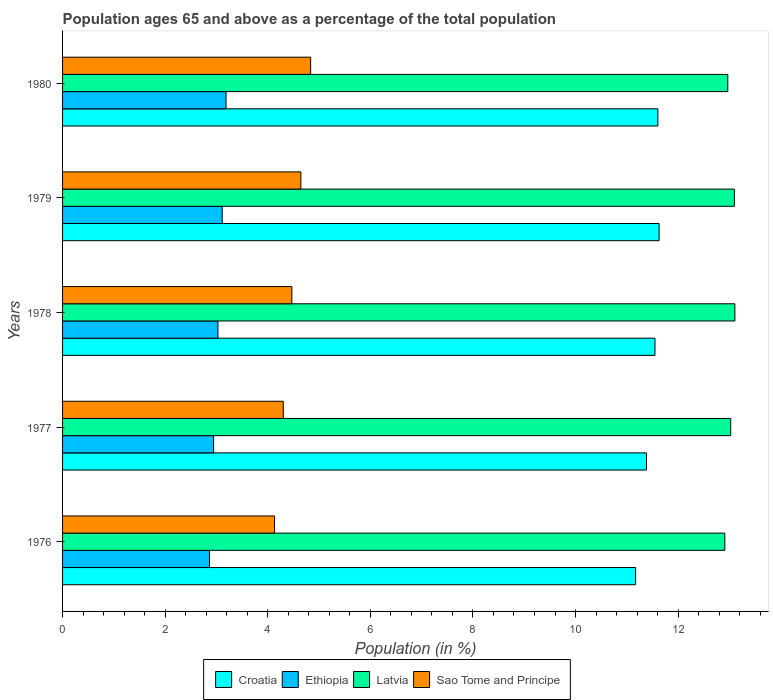How many different coloured bars are there?
Your answer should be compact. 4. Are the number of bars per tick equal to the number of legend labels?
Make the answer very short. Yes. How many bars are there on the 4th tick from the bottom?
Provide a short and direct response. 4. What is the label of the 2nd group of bars from the top?
Give a very brief answer. 1979. In how many cases, is the number of bars for a given year not equal to the number of legend labels?
Give a very brief answer. 0. What is the percentage of the population ages 65 and above in Ethiopia in 1977?
Ensure brevity in your answer.  2.94. Across all years, what is the maximum percentage of the population ages 65 and above in Sao Tome and Principe?
Your answer should be compact. 4.84. Across all years, what is the minimum percentage of the population ages 65 and above in Sao Tome and Principe?
Ensure brevity in your answer.  4.13. In which year was the percentage of the population ages 65 and above in Sao Tome and Principe minimum?
Provide a short and direct response. 1976. What is the total percentage of the population ages 65 and above in Sao Tome and Principe in the graph?
Ensure brevity in your answer.  22.39. What is the difference between the percentage of the population ages 65 and above in Sao Tome and Principe in 1977 and that in 1979?
Offer a terse response. -0.34. What is the difference between the percentage of the population ages 65 and above in Latvia in 1980 and the percentage of the population ages 65 and above in Ethiopia in 1978?
Provide a succinct answer. 9.94. What is the average percentage of the population ages 65 and above in Sao Tome and Principe per year?
Keep it short and to the point. 4.48. In the year 1977, what is the difference between the percentage of the population ages 65 and above in Ethiopia and percentage of the population ages 65 and above in Sao Tome and Principe?
Provide a short and direct response. -1.36. What is the ratio of the percentage of the population ages 65 and above in Ethiopia in 1977 to that in 1978?
Your answer should be very brief. 0.97. Is the percentage of the population ages 65 and above in Croatia in 1979 less than that in 1980?
Give a very brief answer. No. What is the difference between the highest and the second highest percentage of the population ages 65 and above in Sao Tome and Principe?
Offer a terse response. 0.19. What is the difference between the highest and the lowest percentage of the population ages 65 and above in Sao Tome and Principe?
Make the answer very short. 0.7. In how many years, is the percentage of the population ages 65 and above in Ethiopia greater than the average percentage of the population ages 65 and above in Ethiopia taken over all years?
Provide a succinct answer. 3. Is it the case that in every year, the sum of the percentage of the population ages 65 and above in Sao Tome and Principe and percentage of the population ages 65 and above in Latvia is greater than the sum of percentage of the population ages 65 and above in Ethiopia and percentage of the population ages 65 and above in Croatia?
Make the answer very short. Yes. What does the 1st bar from the top in 1977 represents?
Offer a terse response. Sao Tome and Principe. What does the 4th bar from the bottom in 1976 represents?
Offer a very short reply. Sao Tome and Principe. How many years are there in the graph?
Give a very brief answer. 5. Are the values on the major ticks of X-axis written in scientific E-notation?
Keep it short and to the point. No. Does the graph contain any zero values?
Your answer should be very brief. No. Does the graph contain grids?
Your answer should be very brief. No. Where does the legend appear in the graph?
Offer a very short reply. Bottom center. How many legend labels are there?
Keep it short and to the point. 4. How are the legend labels stacked?
Make the answer very short. Horizontal. What is the title of the graph?
Make the answer very short. Population ages 65 and above as a percentage of the total population. What is the Population (in %) of Croatia in 1976?
Keep it short and to the point. 11.17. What is the Population (in %) of Ethiopia in 1976?
Your response must be concise. 2.86. What is the Population (in %) in Latvia in 1976?
Ensure brevity in your answer.  12.91. What is the Population (in %) of Sao Tome and Principe in 1976?
Provide a short and direct response. 4.13. What is the Population (in %) in Croatia in 1977?
Ensure brevity in your answer.  11.38. What is the Population (in %) of Ethiopia in 1977?
Give a very brief answer. 2.94. What is the Population (in %) of Latvia in 1977?
Make the answer very short. 13.02. What is the Population (in %) in Sao Tome and Principe in 1977?
Offer a terse response. 4.3. What is the Population (in %) of Croatia in 1978?
Your response must be concise. 11.55. What is the Population (in %) of Ethiopia in 1978?
Offer a terse response. 3.03. What is the Population (in %) in Latvia in 1978?
Your answer should be compact. 13.11. What is the Population (in %) of Sao Tome and Principe in 1978?
Provide a short and direct response. 4.47. What is the Population (in %) of Croatia in 1979?
Offer a terse response. 11.63. What is the Population (in %) in Ethiopia in 1979?
Provide a short and direct response. 3.11. What is the Population (in %) of Latvia in 1979?
Give a very brief answer. 13.1. What is the Population (in %) in Sao Tome and Principe in 1979?
Your answer should be compact. 4.65. What is the Population (in %) in Croatia in 1980?
Offer a terse response. 11.61. What is the Population (in %) in Ethiopia in 1980?
Your answer should be compact. 3.19. What is the Population (in %) in Latvia in 1980?
Ensure brevity in your answer.  12.97. What is the Population (in %) in Sao Tome and Principe in 1980?
Offer a very short reply. 4.84. Across all years, what is the maximum Population (in %) of Croatia?
Provide a succinct answer. 11.63. Across all years, what is the maximum Population (in %) of Ethiopia?
Your answer should be very brief. 3.19. Across all years, what is the maximum Population (in %) in Latvia?
Your response must be concise. 13.11. Across all years, what is the maximum Population (in %) of Sao Tome and Principe?
Keep it short and to the point. 4.84. Across all years, what is the minimum Population (in %) in Croatia?
Provide a short and direct response. 11.17. Across all years, what is the minimum Population (in %) in Ethiopia?
Your answer should be very brief. 2.86. Across all years, what is the minimum Population (in %) in Latvia?
Keep it short and to the point. 12.91. Across all years, what is the minimum Population (in %) in Sao Tome and Principe?
Your answer should be very brief. 4.13. What is the total Population (in %) of Croatia in the graph?
Your answer should be compact. 57.34. What is the total Population (in %) in Ethiopia in the graph?
Make the answer very short. 15.14. What is the total Population (in %) in Latvia in the graph?
Your answer should be very brief. 65.11. What is the total Population (in %) of Sao Tome and Principe in the graph?
Offer a very short reply. 22.39. What is the difference between the Population (in %) of Croatia in 1976 and that in 1977?
Make the answer very short. -0.21. What is the difference between the Population (in %) in Ethiopia in 1976 and that in 1977?
Offer a very short reply. -0.08. What is the difference between the Population (in %) of Latvia in 1976 and that in 1977?
Your answer should be compact. -0.11. What is the difference between the Population (in %) of Sao Tome and Principe in 1976 and that in 1977?
Provide a short and direct response. -0.17. What is the difference between the Population (in %) in Croatia in 1976 and that in 1978?
Provide a short and direct response. -0.38. What is the difference between the Population (in %) in Ethiopia in 1976 and that in 1978?
Your response must be concise. -0.17. What is the difference between the Population (in %) of Latvia in 1976 and that in 1978?
Your answer should be compact. -0.2. What is the difference between the Population (in %) of Sao Tome and Principe in 1976 and that in 1978?
Make the answer very short. -0.34. What is the difference between the Population (in %) of Croatia in 1976 and that in 1979?
Offer a terse response. -0.46. What is the difference between the Population (in %) in Ethiopia in 1976 and that in 1979?
Make the answer very short. -0.25. What is the difference between the Population (in %) of Latvia in 1976 and that in 1979?
Provide a succinct answer. -0.19. What is the difference between the Population (in %) in Sao Tome and Principe in 1976 and that in 1979?
Provide a succinct answer. -0.51. What is the difference between the Population (in %) of Croatia in 1976 and that in 1980?
Offer a terse response. -0.43. What is the difference between the Population (in %) of Ethiopia in 1976 and that in 1980?
Provide a short and direct response. -0.32. What is the difference between the Population (in %) of Latvia in 1976 and that in 1980?
Your answer should be very brief. -0.06. What is the difference between the Population (in %) of Sao Tome and Principe in 1976 and that in 1980?
Make the answer very short. -0.7. What is the difference between the Population (in %) of Croatia in 1977 and that in 1978?
Your response must be concise. -0.17. What is the difference between the Population (in %) in Ethiopia in 1977 and that in 1978?
Make the answer very short. -0.08. What is the difference between the Population (in %) of Latvia in 1977 and that in 1978?
Ensure brevity in your answer.  -0.08. What is the difference between the Population (in %) in Sao Tome and Principe in 1977 and that in 1978?
Give a very brief answer. -0.17. What is the difference between the Population (in %) of Croatia in 1977 and that in 1979?
Give a very brief answer. -0.25. What is the difference between the Population (in %) of Ethiopia in 1977 and that in 1979?
Your answer should be very brief. -0.17. What is the difference between the Population (in %) of Latvia in 1977 and that in 1979?
Your answer should be very brief. -0.07. What is the difference between the Population (in %) in Sao Tome and Principe in 1977 and that in 1979?
Your answer should be compact. -0.34. What is the difference between the Population (in %) in Croatia in 1977 and that in 1980?
Keep it short and to the point. -0.22. What is the difference between the Population (in %) of Ethiopia in 1977 and that in 1980?
Provide a succinct answer. -0.24. What is the difference between the Population (in %) in Latvia in 1977 and that in 1980?
Your answer should be compact. 0.06. What is the difference between the Population (in %) of Sao Tome and Principe in 1977 and that in 1980?
Keep it short and to the point. -0.53. What is the difference between the Population (in %) in Croatia in 1978 and that in 1979?
Your response must be concise. -0.08. What is the difference between the Population (in %) in Ethiopia in 1978 and that in 1979?
Offer a terse response. -0.08. What is the difference between the Population (in %) in Latvia in 1978 and that in 1979?
Offer a very short reply. 0.01. What is the difference between the Population (in %) in Sao Tome and Principe in 1978 and that in 1979?
Your response must be concise. -0.18. What is the difference between the Population (in %) in Croatia in 1978 and that in 1980?
Provide a short and direct response. -0.06. What is the difference between the Population (in %) in Ethiopia in 1978 and that in 1980?
Your answer should be very brief. -0.16. What is the difference between the Population (in %) of Latvia in 1978 and that in 1980?
Give a very brief answer. 0.14. What is the difference between the Population (in %) of Sao Tome and Principe in 1978 and that in 1980?
Offer a terse response. -0.37. What is the difference between the Population (in %) in Croatia in 1979 and that in 1980?
Offer a terse response. 0.02. What is the difference between the Population (in %) of Ethiopia in 1979 and that in 1980?
Offer a terse response. -0.07. What is the difference between the Population (in %) in Latvia in 1979 and that in 1980?
Offer a terse response. 0.13. What is the difference between the Population (in %) of Sao Tome and Principe in 1979 and that in 1980?
Give a very brief answer. -0.19. What is the difference between the Population (in %) of Croatia in 1976 and the Population (in %) of Ethiopia in 1977?
Offer a very short reply. 8.23. What is the difference between the Population (in %) of Croatia in 1976 and the Population (in %) of Latvia in 1977?
Your response must be concise. -1.85. What is the difference between the Population (in %) in Croatia in 1976 and the Population (in %) in Sao Tome and Principe in 1977?
Provide a short and direct response. 6.87. What is the difference between the Population (in %) in Ethiopia in 1976 and the Population (in %) in Latvia in 1977?
Your answer should be compact. -10.16. What is the difference between the Population (in %) of Ethiopia in 1976 and the Population (in %) of Sao Tome and Principe in 1977?
Your answer should be compact. -1.44. What is the difference between the Population (in %) of Latvia in 1976 and the Population (in %) of Sao Tome and Principe in 1977?
Provide a short and direct response. 8.61. What is the difference between the Population (in %) of Croatia in 1976 and the Population (in %) of Ethiopia in 1978?
Offer a terse response. 8.14. What is the difference between the Population (in %) of Croatia in 1976 and the Population (in %) of Latvia in 1978?
Give a very brief answer. -1.94. What is the difference between the Population (in %) of Croatia in 1976 and the Population (in %) of Sao Tome and Principe in 1978?
Your answer should be compact. 6.7. What is the difference between the Population (in %) in Ethiopia in 1976 and the Population (in %) in Latvia in 1978?
Your response must be concise. -10.24. What is the difference between the Population (in %) of Ethiopia in 1976 and the Population (in %) of Sao Tome and Principe in 1978?
Your answer should be compact. -1.61. What is the difference between the Population (in %) of Latvia in 1976 and the Population (in %) of Sao Tome and Principe in 1978?
Your answer should be very brief. 8.44. What is the difference between the Population (in %) in Croatia in 1976 and the Population (in %) in Ethiopia in 1979?
Make the answer very short. 8.06. What is the difference between the Population (in %) in Croatia in 1976 and the Population (in %) in Latvia in 1979?
Make the answer very short. -1.93. What is the difference between the Population (in %) in Croatia in 1976 and the Population (in %) in Sao Tome and Principe in 1979?
Provide a succinct answer. 6.53. What is the difference between the Population (in %) of Ethiopia in 1976 and the Population (in %) of Latvia in 1979?
Your response must be concise. -10.23. What is the difference between the Population (in %) of Ethiopia in 1976 and the Population (in %) of Sao Tome and Principe in 1979?
Your answer should be compact. -1.78. What is the difference between the Population (in %) in Latvia in 1976 and the Population (in %) in Sao Tome and Principe in 1979?
Your response must be concise. 8.26. What is the difference between the Population (in %) of Croatia in 1976 and the Population (in %) of Ethiopia in 1980?
Provide a short and direct response. 7.98. What is the difference between the Population (in %) of Croatia in 1976 and the Population (in %) of Latvia in 1980?
Provide a succinct answer. -1.8. What is the difference between the Population (in %) in Croatia in 1976 and the Population (in %) in Sao Tome and Principe in 1980?
Offer a very short reply. 6.34. What is the difference between the Population (in %) of Ethiopia in 1976 and the Population (in %) of Latvia in 1980?
Offer a very short reply. -10.11. What is the difference between the Population (in %) of Ethiopia in 1976 and the Population (in %) of Sao Tome and Principe in 1980?
Give a very brief answer. -1.97. What is the difference between the Population (in %) of Latvia in 1976 and the Population (in %) of Sao Tome and Principe in 1980?
Offer a terse response. 8.07. What is the difference between the Population (in %) of Croatia in 1977 and the Population (in %) of Ethiopia in 1978?
Make the answer very short. 8.35. What is the difference between the Population (in %) in Croatia in 1977 and the Population (in %) in Latvia in 1978?
Provide a succinct answer. -1.72. What is the difference between the Population (in %) of Croatia in 1977 and the Population (in %) of Sao Tome and Principe in 1978?
Your answer should be very brief. 6.91. What is the difference between the Population (in %) of Ethiopia in 1977 and the Population (in %) of Latvia in 1978?
Provide a short and direct response. -10.16. What is the difference between the Population (in %) in Ethiopia in 1977 and the Population (in %) in Sao Tome and Principe in 1978?
Make the answer very short. -1.53. What is the difference between the Population (in %) in Latvia in 1977 and the Population (in %) in Sao Tome and Principe in 1978?
Ensure brevity in your answer.  8.56. What is the difference between the Population (in %) of Croatia in 1977 and the Population (in %) of Ethiopia in 1979?
Give a very brief answer. 8.27. What is the difference between the Population (in %) in Croatia in 1977 and the Population (in %) in Latvia in 1979?
Your answer should be very brief. -1.71. What is the difference between the Population (in %) of Croatia in 1977 and the Population (in %) of Sao Tome and Principe in 1979?
Give a very brief answer. 6.74. What is the difference between the Population (in %) of Ethiopia in 1977 and the Population (in %) of Latvia in 1979?
Offer a terse response. -10.15. What is the difference between the Population (in %) of Ethiopia in 1977 and the Population (in %) of Sao Tome and Principe in 1979?
Ensure brevity in your answer.  -1.7. What is the difference between the Population (in %) of Latvia in 1977 and the Population (in %) of Sao Tome and Principe in 1979?
Offer a very short reply. 8.38. What is the difference between the Population (in %) in Croatia in 1977 and the Population (in %) in Ethiopia in 1980?
Make the answer very short. 8.2. What is the difference between the Population (in %) of Croatia in 1977 and the Population (in %) of Latvia in 1980?
Ensure brevity in your answer.  -1.59. What is the difference between the Population (in %) in Croatia in 1977 and the Population (in %) in Sao Tome and Principe in 1980?
Provide a short and direct response. 6.55. What is the difference between the Population (in %) in Ethiopia in 1977 and the Population (in %) in Latvia in 1980?
Your response must be concise. -10.02. What is the difference between the Population (in %) in Ethiopia in 1977 and the Population (in %) in Sao Tome and Principe in 1980?
Offer a very short reply. -1.89. What is the difference between the Population (in %) of Latvia in 1977 and the Population (in %) of Sao Tome and Principe in 1980?
Your answer should be compact. 8.19. What is the difference between the Population (in %) of Croatia in 1978 and the Population (in %) of Ethiopia in 1979?
Keep it short and to the point. 8.44. What is the difference between the Population (in %) of Croatia in 1978 and the Population (in %) of Latvia in 1979?
Offer a very short reply. -1.55. What is the difference between the Population (in %) of Croatia in 1978 and the Population (in %) of Sao Tome and Principe in 1979?
Your answer should be very brief. 6.9. What is the difference between the Population (in %) in Ethiopia in 1978 and the Population (in %) in Latvia in 1979?
Your answer should be compact. -10.07. What is the difference between the Population (in %) in Ethiopia in 1978 and the Population (in %) in Sao Tome and Principe in 1979?
Offer a terse response. -1.62. What is the difference between the Population (in %) in Latvia in 1978 and the Population (in %) in Sao Tome and Principe in 1979?
Give a very brief answer. 8.46. What is the difference between the Population (in %) of Croatia in 1978 and the Population (in %) of Ethiopia in 1980?
Ensure brevity in your answer.  8.36. What is the difference between the Population (in %) of Croatia in 1978 and the Population (in %) of Latvia in 1980?
Make the answer very short. -1.42. What is the difference between the Population (in %) of Croatia in 1978 and the Population (in %) of Sao Tome and Principe in 1980?
Your answer should be compact. 6.71. What is the difference between the Population (in %) of Ethiopia in 1978 and the Population (in %) of Latvia in 1980?
Offer a very short reply. -9.94. What is the difference between the Population (in %) in Ethiopia in 1978 and the Population (in %) in Sao Tome and Principe in 1980?
Your response must be concise. -1.81. What is the difference between the Population (in %) in Latvia in 1978 and the Population (in %) in Sao Tome and Principe in 1980?
Make the answer very short. 8.27. What is the difference between the Population (in %) in Croatia in 1979 and the Population (in %) in Ethiopia in 1980?
Your answer should be very brief. 8.44. What is the difference between the Population (in %) in Croatia in 1979 and the Population (in %) in Latvia in 1980?
Provide a succinct answer. -1.34. What is the difference between the Population (in %) of Croatia in 1979 and the Population (in %) of Sao Tome and Principe in 1980?
Provide a succinct answer. 6.79. What is the difference between the Population (in %) of Ethiopia in 1979 and the Population (in %) of Latvia in 1980?
Give a very brief answer. -9.86. What is the difference between the Population (in %) in Ethiopia in 1979 and the Population (in %) in Sao Tome and Principe in 1980?
Offer a terse response. -1.72. What is the difference between the Population (in %) in Latvia in 1979 and the Population (in %) in Sao Tome and Principe in 1980?
Keep it short and to the point. 8.26. What is the average Population (in %) of Croatia per year?
Ensure brevity in your answer.  11.47. What is the average Population (in %) in Ethiopia per year?
Give a very brief answer. 3.03. What is the average Population (in %) in Latvia per year?
Ensure brevity in your answer.  13.02. What is the average Population (in %) of Sao Tome and Principe per year?
Provide a short and direct response. 4.48. In the year 1976, what is the difference between the Population (in %) in Croatia and Population (in %) in Ethiopia?
Make the answer very short. 8.31. In the year 1976, what is the difference between the Population (in %) in Croatia and Population (in %) in Latvia?
Offer a terse response. -1.74. In the year 1976, what is the difference between the Population (in %) in Croatia and Population (in %) in Sao Tome and Principe?
Offer a very short reply. 7.04. In the year 1976, what is the difference between the Population (in %) in Ethiopia and Population (in %) in Latvia?
Offer a very short reply. -10.05. In the year 1976, what is the difference between the Population (in %) in Ethiopia and Population (in %) in Sao Tome and Principe?
Keep it short and to the point. -1.27. In the year 1976, what is the difference between the Population (in %) in Latvia and Population (in %) in Sao Tome and Principe?
Provide a succinct answer. 8.78. In the year 1977, what is the difference between the Population (in %) in Croatia and Population (in %) in Ethiopia?
Your response must be concise. 8.44. In the year 1977, what is the difference between the Population (in %) in Croatia and Population (in %) in Latvia?
Provide a succinct answer. -1.64. In the year 1977, what is the difference between the Population (in %) in Croatia and Population (in %) in Sao Tome and Principe?
Your response must be concise. 7.08. In the year 1977, what is the difference between the Population (in %) of Ethiopia and Population (in %) of Latvia?
Your response must be concise. -10.08. In the year 1977, what is the difference between the Population (in %) in Ethiopia and Population (in %) in Sao Tome and Principe?
Your answer should be compact. -1.36. In the year 1977, what is the difference between the Population (in %) of Latvia and Population (in %) of Sao Tome and Principe?
Offer a very short reply. 8.72. In the year 1978, what is the difference between the Population (in %) of Croatia and Population (in %) of Ethiopia?
Keep it short and to the point. 8.52. In the year 1978, what is the difference between the Population (in %) in Croatia and Population (in %) in Latvia?
Your response must be concise. -1.56. In the year 1978, what is the difference between the Population (in %) of Croatia and Population (in %) of Sao Tome and Principe?
Make the answer very short. 7.08. In the year 1978, what is the difference between the Population (in %) of Ethiopia and Population (in %) of Latvia?
Give a very brief answer. -10.08. In the year 1978, what is the difference between the Population (in %) of Ethiopia and Population (in %) of Sao Tome and Principe?
Offer a very short reply. -1.44. In the year 1978, what is the difference between the Population (in %) of Latvia and Population (in %) of Sao Tome and Principe?
Make the answer very short. 8.64. In the year 1979, what is the difference between the Population (in %) of Croatia and Population (in %) of Ethiopia?
Your answer should be very brief. 8.52. In the year 1979, what is the difference between the Population (in %) of Croatia and Population (in %) of Latvia?
Make the answer very short. -1.47. In the year 1979, what is the difference between the Population (in %) of Croatia and Population (in %) of Sao Tome and Principe?
Provide a succinct answer. 6.98. In the year 1979, what is the difference between the Population (in %) of Ethiopia and Population (in %) of Latvia?
Your answer should be very brief. -9.98. In the year 1979, what is the difference between the Population (in %) of Ethiopia and Population (in %) of Sao Tome and Principe?
Give a very brief answer. -1.53. In the year 1979, what is the difference between the Population (in %) in Latvia and Population (in %) in Sao Tome and Principe?
Provide a short and direct response. 8.45. In the year 1980, what is the difference between the Population (in %) in Croatia and Population (in %) in Ethiopia?
Provide a short and direct response. 8.42. In the year 1980, what is the difference between the Population (in %) of Croatia and Population (in %) of Latvia?
Your response must be concise. -1.36. In the year 1980, what is the difference between the Population (in %) of Croatia and Population (in %) of Sao Tome and Principe?
Your answer should be compact. 6.77. In the year 1980, what is the difference between the Population (in %) in Ethiopia and Population (in %) in Latvia?
Make the answer very short. -9.78. In the year 1980, what is the difference between the Population (in %) of Ethiopia and Population (in %) of Sao Tome and Principe?
Offer a terse response. -1.65. In the year 1980, what is the difference between the Population (in %) of Latvia and Population (in %) of Sao Tome and Principe?
Ensure brevity in your answer.  8.13. What is the ratio of the Population (in %) in Croatia in 1976 to that in 1977?
Your answer should be very brief. 0.98. What is the ratio of the Population (in %) of Ethiopia in 1976 to that in 1977?
Ensure brevity in your answer.  0.97. What is the ratio of the Population (in %) of Latvia in 1976 to that in 1977?
Your response must be concise. 0.99. What is the ratio of the Population (in %) in Sao Tome and Principe in 1976 to that in 1977?
Provide a short and direct response. 0.96. What is the ratio of the Population (in %) of Croatia in 1976 to that in 1978?
Ensure brevity in your answer.  0.97. What is the ratio of the Population (in %) in Ethiopia in 1976 to that in 1978?
Keep it short and to the point. 0.95. What is the ratio of the Population (in %) of Latvia in 1976 to that in 1978?
Provide a short and direct response. 0.98. What is the ratio of the Population (in %) in Sao Tome and Principe in 1976 to that in 1978?
Your response must be concise. 0.92. What is the ratio of the Population (in %) in Croatia in 1976 to that in 1979?
Offer a very short reply. 0.96. What is the ratio of the Population (in %) in Latvia in 1976 to that in 1979?
Your response must be concise. 0.99. What is the ratio of the Population (in %) in Sao Tome and Principe in 1976 to that in 1979?
Offer a terse response. 0.89. What is the ratio of the Population (in %) of Croatia in 1976 to that in 1980?
Provide a short and direct response. 0.96. What is the ratio of the Population (in %) of Ethiopia in 1976 to that in 1980?
Give a very brief answer. 0.9. What is the ratio of the Population (in %) of Sao Tome and Principe in 1976 to that in 1980?
Offer a very short reply. 0.85. What is the ratio of the Population (in %) in Croatia in 1977 to that in 1978?
Provide a succinct answer. 0.99. What is the ratio of the Population (in %) of Sao Tome and Principe in 1977 to that in 1978?
Your response must be concise. 0.96. What is the ratio of the Population (in %) in Croatia in 1977 to that in 1979?
Your response must be concise. 0.98. What is the ratio of the Population (in %) in Ethiopia in 1977 to that in 1979?
Keep it short and to the point. 0.95. What is the ratio of the Population (in %) in Latvia in 1977 to that in 1979?
Ensure brevity in your answer.  0.99. What is the ratio of the Population (in %) of Sao Tome and Principe in 1977 to that in 1979?
Your response must be concise. 0.93. What is the ratio of the Population (in %) of Croatia in 1977 to that in 1980?
Offer a very short reply. 0.98. What is the ratio of the Population (in %) of Ethiopia in 1977 to that in 1980?
Provide a succinct answer. 0.92. What is the ratio of the Population (in %) in Latvia in 1977 to that in 1980?
Provide a short and direct response. 1. What is the ratio of the Population (in %) in Sao Tome and Principe in 1977 to that in 1980?
Your answer should be compact. 0.89. What is the ratio of the Population (in %) of Croatia in 1978 to that in 1979?
Give a very brief answer. 0.99. What is the ratio of the Population (in %) of Ethiopia in 1978 to that in 1979?
Your answer should be compact. 0.97. What is the ratio of the Population (in %) in Latvia in 1978 to that in 1979?
Your answer should be compact. 1. What is the ratio of the Population (in %) in Sao Tome and Principe in 1978 to that in 1979?
Your response must be concise. 0.96. What is the ratio of the Population (in %) of Croatia in 1978 to that in 1980?
Make the answer very short. 1. What is the ratio of the Population (in %) of Ethiopia in 1978 to that in 1980?
Your response must be concise. 0.95. What is the ratio of the Population (in %) of Latvia in 1978 to that in 1980?
Provide a short and direct response. 1.01. What is the ratio of the Population (in %) in Sao Tome and Principe in 1978 to that in 1980?
Keep it short and to the point. 0.92. What is the ratio of the Population (in %) in Croatia in 1979 to that in 1980?
Ensure brevity in your answer.  1. What is the ratio of the Population (in %) of Ethiopia in 1979 to that in 1980?
Ensure brevity in your answer.  0.98. What is the ratio of the Population (in %) of Latvia in 1979 to that in 1980?
Offer a very short reply. 1.01. What is the ratio of the Population (in %) of Sao Tome and Principe in 1979 to that in 1980?
Give a very brief answer. 0.96. What is the difference between the highest and the second highest Population (in %) of Croatia?
Your response must be concise. 0.02. What is the difference between the highest and the second highest Population (in %) of Ethiopia?
Keep it short and to the point. 0.07. What is the difference between the highest and the second highest Population (in %) of Latvia?
Your answer should be compact. 0.01. What is the difference between the highest and the second highest Population (in %) of Sao Tome and Principe?
Your answer should be very brief. 0.19. What is the difference between the highest and the lowest Population (in %) of Croatia?
Offer a very short reply. 0.46. What is the difference between the highest and the lowest Population (in %) in Ethiopia?
Offer a terse response. 0.32. What is the difference between the highest and the lowest Population (in %) of Latvia?
Ensure brevity in your answer.  0.2. What is the difference between the highest and the lowest Population (in %) of Sao Tome and Principe?
Provide a succinct answer. 0.7. 